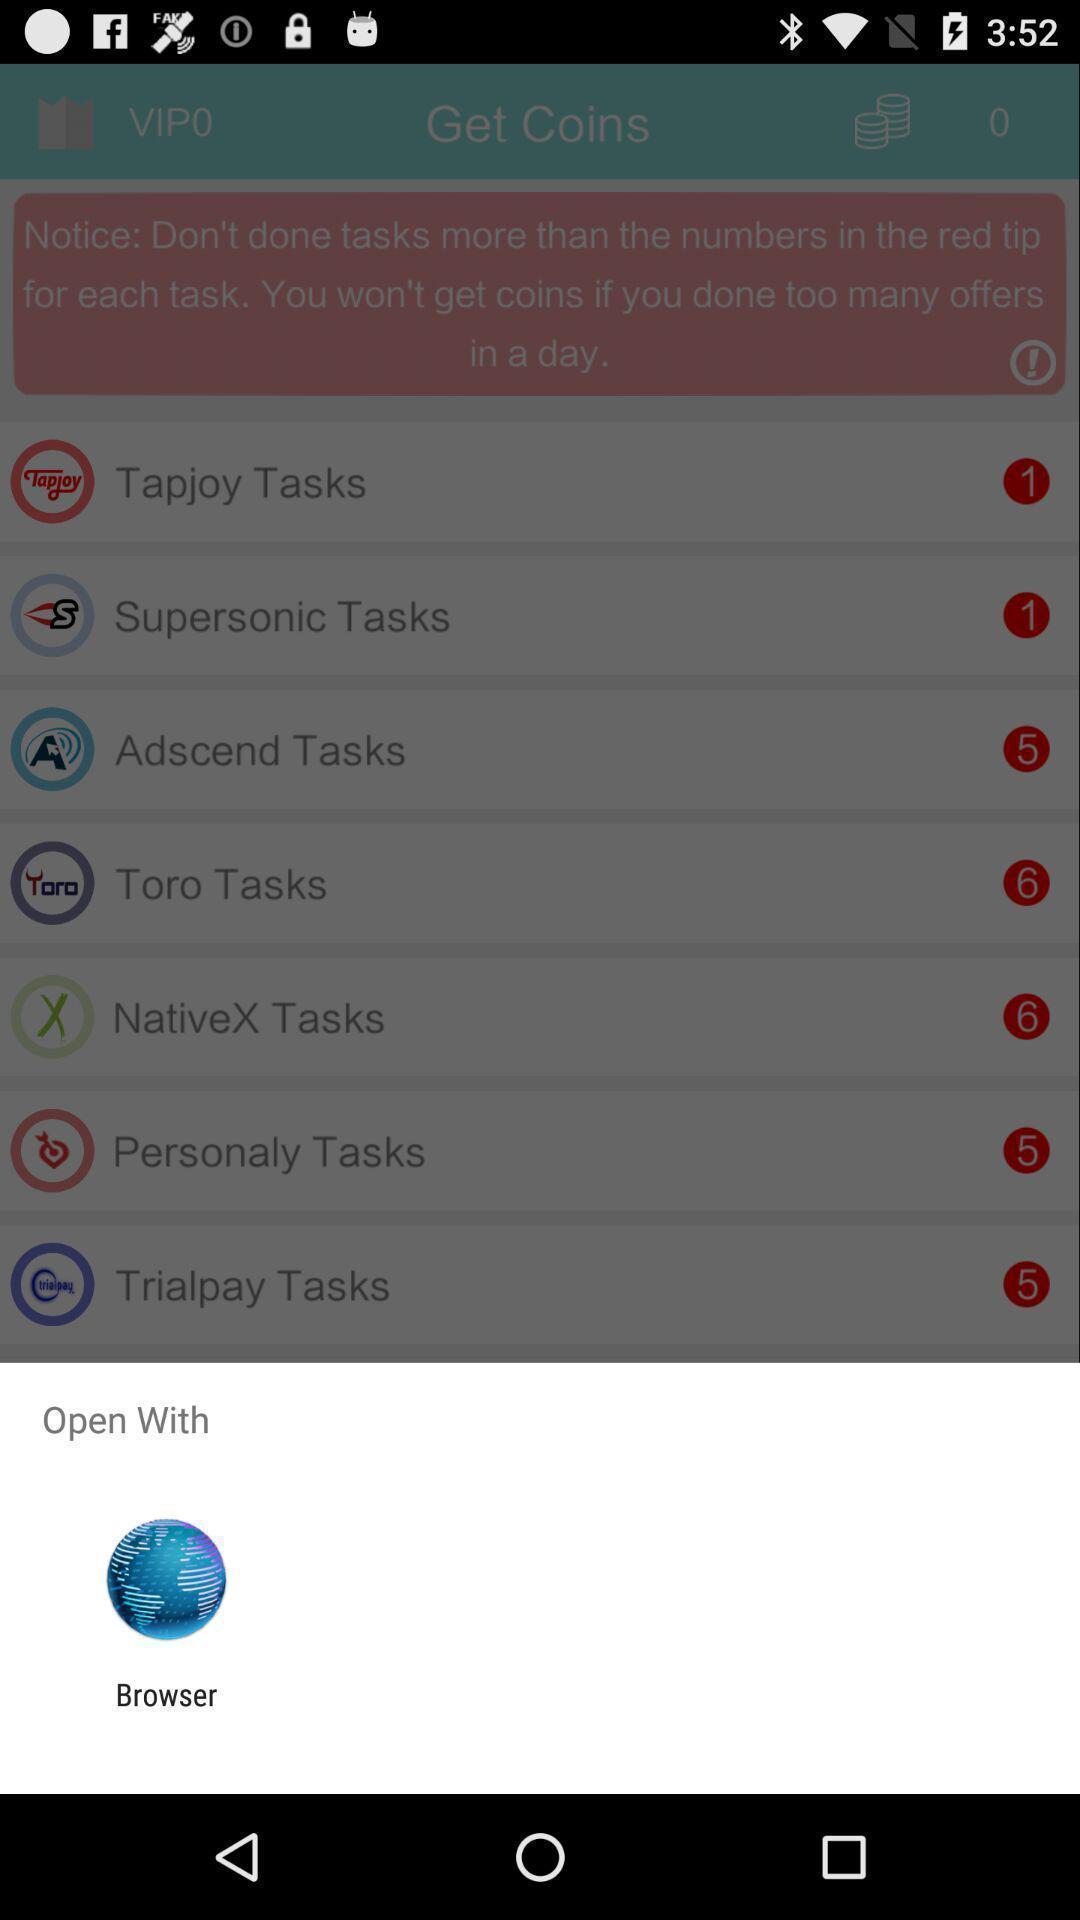What details can you identify in this image? Pop up displaying a browser icon. 